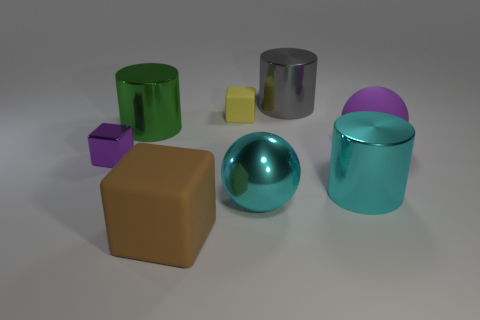Subtract all big green cylinders. How many cylinders are left? 2 Subtract 1 cylinders. How many cylinders are left? 2 Add 1 large cyan things. How many objects exist? 9 Subtract all brown cylinders. Subtract all cyan blocks. How many cylinders are left? 3 Subtract all balls. How many objects are left? 6 Subtract all large purple balls. Subtract all big cylinders. How many objects are left? 4 Add 2 small yellow matte things. How many small yellow matte things are left? 3 Add 2 tiny purple matte objects. How many tiny purple matte objects exist? 2 Subtract 0 gray blocks. How many objects are left? 8 